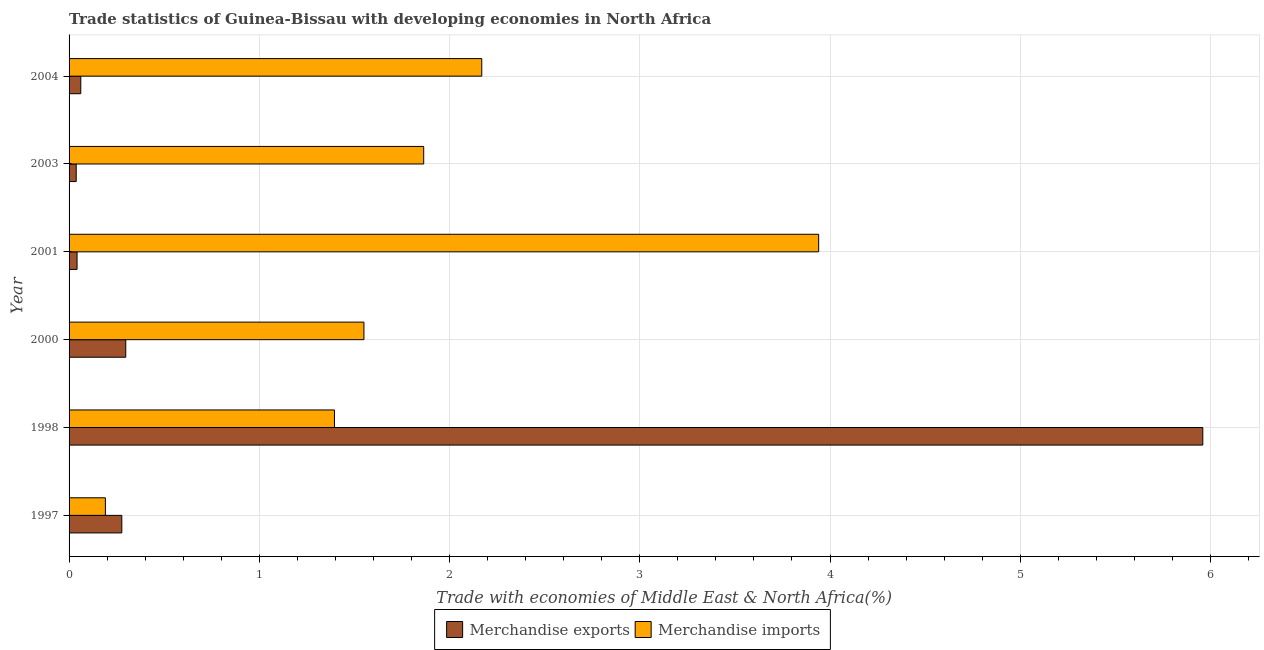How many groups of bars are there?
Offer a very short reply. 6. Are the number of bars on each tick of the Y-axis equal?
Your answer should be very brief. Yes. How many bars are there on the 6th tick from the top?
Provide a short and direct response. 2. What is the merchandise imports in 2003?
Your response must be concise. 1.86. Across all years, what is the maximum merchandise imports?
Keep it short and to the point. 3.94. Across all years, what is the minimum merchandise exports?
Your response must be concise. 0.04. In which year was the merchandise imports maximum?
Keep it short and to the point. 2001. What is the total merchandise imports in the graph?
Make the answer very short. 11.11. What is the difference between the merchandise imports in 2001 and that in 2003?
Your response must be concise. 2.08. What is the difference between the merchandise exports in 1997 and the merchandise imports in 2000?
Ensure brevity in your answer.  -1.27. What is the average merchandise exports per year?
Your response must be concise. 1.11. In the year 1998, what is the difference between the merchandise imports and merchandise exports?
Offer a terse response. -4.56. What is the ratio of the merchandise exports in 2000 to that in 2003?
Make the answer very short. 7.93. What is the difference between the highest and the second highest merchandise imports?
Provide a short and direct response. 1.77. What is the difference between the highest and the lowest merchandise exports?
Offer a very short reply. 5.92. In how many years, is the merchandise exports greater than the average merchandise exports taken over all years?
Offer a very short reply. 1. What does the 1st bar from the bottom in 2003 represents?
Your answer should be compact. Merchandise exports. How many bars are there?
Your answer should be very brief. 12. How many years are there in the graph?
Make the answer very short. 6. What is the difference between two consecutive major ticks on the X-axis?
Offer a very short reply. 1. Are the values on the major ticks of X-axis written in scientific E-notation?
Ensure brevity in your answer.  No. Does the graph contain any zero values?
Provide a short and direct response. No. How are the legend labels stacked?
Keep it short and to the point. Horizontal. What is the title of the graph?
Keep it short and to the point. Trade statistics of Guinea-Bissau with developing economies in North Africa. Does "Secondary Education" appear as one of the legend labels in the graph?
Ensure brevity in your answer.  No. What is the label or title of the X-axis?
Provide a succinct answer. Trade with economies of Middle East & North Africa(%). What is the Trade with economies of Middle East & North Africa(%) in Merchandise exports in 1997?
Give a very brief answer. 0.28. What is the Trade with economies of Middle East & North Africa(%) of Merchandise imports in 1997?
Keep it short and to the point. 0.19. What is the Trade with economies of Middle East & North Africa(%) of Merchandise exports in 1998?
Your answer should be very brief. 5.96. What is the Trade with economies of Middle East & North Africa(%) in Merchandise imports in 1998?
Your response must be concise. 1.4. What is the Trade with economies of Middle East & North Africa(%) of Merchandise exports in 2000?
Offer a terse response. 0.3. What is the Trade with economies of Middle East & North Africa(%) of Merchandise imports in 2000?
Give a very brief answer. 1.55. What is the Trade with economies of Middle East & North Africa(%) of Merchandise exports in 2001?
Keep it short and to the point. 0.04. What is the Trade with economies of Middle East & North Africa(%) in Merchandise imports in 2001?
Your response must be concise. 3.94. What is the Trade with economies of Middle East & North Africa(%) in Merchandise exports in 2003?
Offer a very short reply. 0.04. What is the Trade with economies of Middle East & North Africa(%) of Merchandise imports in 2003?
Give a very brief answer. 1.86. What is the Trade with economies of Middle East & North Africa(%) in Merchandise exports in 2004?
Give a very brief answer. 0.06. What is the Trade with economies of Middle East & North Africa(%) in Merchandise imports in 2004?
Your response must be concise. 2.17. Across all years, what is the maximum Trade with economies of Middle East & North Africa(%) of Merchandise exports?
Give a very brief answer. 5.96. Across all years, what is the maximum Trade with economies of Middle East & North Africa(%) of Merchandise imports?
Provide a short and direct response. 3.94. Across all years, what is the minimum Trade with economies of Middle East & North Africa(%) in Merchandise exports?
Keep it short and to the point. 0.04. Across all years, what is the minimum Trade with economies of Middle East & North Africa(%) of Merchandise imports?
Your answer should be very brief. 0.19. What is the total Trade with economies of Middle East & North Africa(%) of Merchandise exports in the graph?
Offer a terse response. 6.68. What is the total Trade with economies of Middle East & North Africa(%) in Merchandise imports in the graph?
Offer a terse response. 11.11. What is the difference between the Trade with economies of Middle East & North Africa(%) in Merchandise exports in 1997 and that in 1998?
Provide a short and direct response. -5.68. What is the difference between the Trade with economies of Middle East & North Africa(%) in Merchandise imports in 1997 and that in 1998?
Your answer should be compact. -1.2. What is the difference between the Trade with economies of Middle East & North Africa(%) of Merchandise exports in 1997 and that in 2000?
Your answer should be very brief. -0.02. What is the difference between the Trade with economies of Middle East & North Africa(%) in Merchandise imports in 1997 and that in 2000?
Provide a succinct answer. -1.36. What is the difference between the Trade with economies of Middle East & North Africa(%) of Merchandise exports in 1997 and that in 2001?
Make the answer very short. 0.24. What is the difference between the Trade with economies of Middle East & North Africa(%) of Merchandise imports in 1997 and that in 2001?
Your answer should be very brief. -3.75. What is the difference between the Trade with economies of Middle East & North Africa(%) in Merchandise exports in 1997 and that in 2003?
Give a very brief answer. 0.24. What is the difference between the Trade with economies of Middle East & North Africa(%) in Merchandise imports in 1997 and that in 2003?
Make the answer very short. -1.67. What is the difference between the Trade with economies of Middle East & North Africa(%) in Merchandise exports in 1997 and that in 2004?
Offer a very short reply. 0.22. What is the difference between the Trade with economies of Middle East & North Africa(%) in Merchandise imports in 1997 and that in 2004?
Keep it short and to the point. -1.98. What is the difference between the Trade with economies of Middle East & North Africa(%) of Merchandise exports in 1998 and that in 2000?
Provide a short and direct response. 5.66. What is the difference between the Trade with economies of Middle East & North Africa(%) of Merchandise imports in 1998 and that in 2000?
Your answer should be very brief. -0.15. What is the difference between the Trade with economies of Middle East & North Africa(%) in Merchandise exports in 1998 and that in 2001?
Offer a very short reply. 5.92. What is the difference between the Trade with economies of Middle East & North Africa(%) in Merchandise imports in 1998 and that in 2001?
Provide a short and direct response. -2.55. What is the difference between the Trade with economies of Middle East & North Africa(%) of Merchandise exports in 1998 and that in 2003?
Your response must be concise. 5.92. What is the difference between the Trade with economies of Middle East & North Africa(%) in Merchandise imports in 1998 and that in 2003?
Keep it short and to the point. -0.47. What is the difference between the Trade with economies of Middle East & North Africa(%) in Merchandise exports in 1998 and that in 2004?
Provide a short and direct response. 5.9. What is the difference between the Trade with economies of Middle East & North Africa(%) of Merchandise imports in 1998 and that in 2004?
Keep it short and to the point. -0.77. What is the difference between the Trade with economies of Middle East & North Africa(%) of Merchandise exports in 2000 and that in 2001?
Give a very brief answer. 0.26. What is the difference between the Trade with economies of Middle East & North Africa(%) of Merchandise imports in 2000 and that in 2001?
Give a very brief answer. -2.39. What is the difference between the Trade with economies of Middle East & North Africa(%) in Merchandise exports in 2000 and that in 2003?
Ensure brevity in your answer.  0.26. What is the difference between the Trade with economies of Middle East & North Africa(%) of Merchandise imports in 2000 and that in 2003?
Ensure brevity in your answer.  -0.31. What is the difference between the Trade with economies of Middle East & North Africa(%) of Merchandise exports in 2000 and that in 2004?
Make the answer very short. 0.24. What is the difference between the Trade with economies of Middle East & North Africa(%) in Merchandise imports in 2000 and that in 2004?
Offer a terse response. -0.62. What is the difference between the Trade with economies of Middle East & North Africa(%) of Merchandise exports in 2001 and that in 2003?
Your answer should be compact. 0. What is the difference between the Trade with economies of Middle East & North Africa(%) of Merchandise imports in 2001 and that in 2003?
Provide a succinct answer. 2.08. What is the difference between the Trade with economies of Middle East & North Africa(%) of Merchandise exports in 2001 and that in 2004?
Ensure brevity in your answer.  -0.02. What is the difference between the Trade with economies of Middle East & North Africa(%) in Merchandise imports in 2001 and that in 2004?
Offer a terse response. 1.77. What is the difference between the Trade with economies of Middle East & North Africa(%) of Merchandise exports in 2003 and that in 2004?
Give a very brief answer. -0.02. What is the difference between the Trade with economies of Middle East & North Africa(%) in Merchandise imports in 2003 and that in 2004?
Make the answer very short. -0.31. What is the difference between the Trade with economies of Middle East & North Africa(%) in Merchandise exports in 1997 and the Trade with economies of Middle East & North Africa(%) in Merchandise imports in 1998?
Provide a short and direct response. -1.12. What is the difference between the Trade with economies of Middle East & North Africa(%) of Merchandise exports in 1997 and the Trade with economies of Middle East & North Africa(%) of Merchandise imports in 2000?
Keep it short and to the point. -1.27. What is the difference between the Trade with economies of Middle East & North Africa(%) in Merchandise exports in 1997 and the Trade with economies of Middle East & North Africa(%) in Merchandise imports in 2001?
Make the answer very short. -3.66. What is the difference between the Trade with economies of Middle East & North Africa(%) in Merchandise exports in 1997 and the Trade with economies of Middle East & North Africa(%) in Merchandise imports in 2003?
Offer a very short reply. -1.59. What is the difference between the Trade with economies of Middle East & North Africa(%) of Merchandise exports in 1997 and the Trade with economies of Middle East & North Africa(%) of Merchandise imports in 2004?
Your response must be concise. -1.89. What is the difference between the Trade with economies of Middle East & North Africa(%) in Merchandise exports in 1998 and the Trade with economies of Middle East & North Africa(%) in Merchandise imports in 2000?
Make the answer very short. 4.41. What is the difference between the Trade with economies of Middle East & North Africa(%) in Merchandise exports in 1998 and the Trade with economies of Middle East & North Africa(%) in Merchandise imports in 2001?
Provide a short and direct response. 2.02. What is the difference between the Trade with economies of Middle East & North Africa(%) in Merchandise exports in 1998 and the Trade with economies of Middle East & North Africa(%) in Merchandise imports in 2003?
Keep it short and to the point. 4.1. What is the difference between the Trade with economies of Middle East & North Africa(%) of Merchandise exports in 1998 and the Trade with economies of Middle East & North Africa(%) of Merchandise imports in 2004?
Provide a succinct answer. 3.79. What is the difference between the Trade with economies of Middle East & North Africa(%) in Merchandise exports in 2000 and the Trade with economies of Middle East & North Africa(%) in Merchandise imports in 2001?
Provide a succinct answer. -3.64. What is the difference between the Trade with economies of Middle East & North Africa(%) in Merchandise exports in 2000 and the Trade with economies of Middle East & North Africa(%) in Merchandise imports in 2003?
Give a very brief answer. -1.57. What is the difference between the Trade with economies of Middle East & North Africa(%) of Merchandise exports in 2000 and the Trade with economies of Middle East & North Africa(%) of Merchandise imports in 2004?
Keep it short and to the point. -1.87. What is the difference between the Trade with economies of Middle East & North Africa(%) in Merchandise exports in 2001 and the Trade with economies of Middle East & North Africa(%) in Merchandise imports in 2003?
Your answer should be compact. -1.82. What is the difference between the Trade with economies of Middle East & North Africa(%) of Merchandise exports in 2001 and the Trade with economies of Middle East & North Africa(%) of Merchandise imports in 2004?
Offer a very short reply. -2.13. What is the difference between the Trade with economies of Middle East & North Africa(%) of Merchandise exports in 2003 and the Trade with economies of Middle East & North Africa(%) of Merchandise imports in 2004?
Give a very brief answer. -2.13. What is the average Trade with economies of Middle East & North Africa(%) in Merchandise exports per year?
Make the answer very short. 1.11. What is the average Trade with economies of Middle East & North Africa(%) in Merchandise imports per year?
Your answer should be very brief. 1.85. In the year 1997, what is the difference between the Trade with economies of Middle East & North Africa(%) in Merchandise exports and Trade with economies of Middle East & North Africa(%) in Merchandise imports?
Your answer should be very brief. 0.09. In the year 1998, what is the difference between the Trade with economies of Middle East & North Africa(%) in Merchandise exports and Trade with economies of Middle East & North Africa(%) in Merchandise imports?
Give a very brief answer. 4.56. In the year 2000, what is the difference between the Trade with economies of Middle East & North Africa(%) in Merchandise exports and Trade with economies of Middle East & North Africa(%) in Merchandise imports?
Provide a succinct answer. -1.25. In the year 2001, what is the difference between the Trade with economies of Middle East & North Africa(%) in Merchandise exports and Trade with economies of Middle East & North Africa(%) in Merchandise imports?
Keep it short and to the point. -3.9. In the year 2003, what is the difference between the Trade with economies of Middle East & North Africa(%) in Merchandise exports and Trade with economies of Middle East & North Africa(%) in Merchandise imports?
Make the answer very short. -1.83. In the year 2004, what is the difference between the Trade with economies of Middle East & North Africa(%) of Merchandise exports and Trade with economies of Middle East & North Africa(%) of Merchandise imports?
Your answer should be very brief. -2.11. What is the ratio of the Trade with economies of Middle East & North Africa(%) in Merchandise exports in 1997 to that in 1998?
Keep it short and to the point. 0.05. What is the ratio of the Trade with economies of Middle East & North Africa(%) in Merchandise imports in 1997 to that in 1998?
Your response must be concise. 0.14. What is the ratio of the Trade with economies of Middle East & North Africa(%) in Merchandise exports in 1997 to that in 2000?
Ensure brevity in your answer.  0.93. What is the ratio of the Trade with economies of Middle East & North Africa(%) of Merchandise imports in 1997 to that in 2000?
Keep it short and to the point. 0.12. What is the ratio of the Trade with economies of Middle East & North Africa(%) of Merchandise exports in 1997 to that in 2001?
Give a very brief answer. 6.6. What is the ratio of the Trade with economies of Middle East & North Africa(%) in Merchandise imports in 1997 to that in 2001?
Your answer should be very brief. 0.05. What is the ratio of the Trade with economies of Middle East & North Africa(%) of Merchandise exports in 1997 to that in 2003?
Provide a succinct answer. 7.37. What is the ratio of the Trade with economies of Middle East & North Africa(%) of Merchandise imports in 1997 to that in 2003?
Ensure brevity in your answer.  0.1. What is the ratio of the Trade with economies of Middle East & North Africa(%) of Merchandise exports in 1997 to that in 2004?
Ensure brevity in your answer.  4.5. What is the ratio of the Trade with economies of Middle East & North Africa(%) of Merchandise imports in 1997 to that in 2004?
Your answer should be very brief. 0.09. What is the ratio of the Trade with economies of Middle East & North Africa(%) in Merchandise exports in 1998 to that in 2000?
Make the answer very short. 20. What is the ratio of the Trade with economies of Middle East & North Africa(%) of Merchandise imports in 1998 to that in 2000?
Make the answer very short. 0.9. What is the ratio of the Trade with economies of Middle East & North Africa(%) of Merchandise exports in 1998 to that in 2001?
Offer a terse response. 141.95. What is the ratio of the Trade with economies of Middle East & North Africa(%) of Merchandise imports in 1998 to that in 2001?
Provide a succinct answer. 0.35. What is the ratio of the Trade with economies of Middle East & North Africa(%) in Merchandise exports in 1998 to that in 2003?
Offer a very short reply. 158.51. What is the ratio of the Trade with economies of Middle East & North Africa(%) in Merchandise imports in 1998 to that in 2003?
Ensure brevity in your answer.  0.75. What is the ratio of the Trade with economies of Middle East & North Africa(%) of Merchandise exports in 1998 to that in 2004?
Keep it short and to the point. 96.81. What is the ratio of the Trade with economies of Middle East & North Africa(%) in Merchandise imports in 1998 to that in 2004?
Provide a short and direct response. 0.64. What is the ratio of the Trade with economies of Middle East & North Africa(%) in Merchandise exports in 2000 to that in 2001?
Make the answer very short. 7.1. What is the ratio of the Trade with economies of Middle East & North Africa(%) in Merchandise imports in 2000 to that in 2001?
Your answer should be compact. 0.39. What is the ratio of the Trade with economies of Middle East & North Africa(%) in Merchandise exports in 2000 to that in 2003?
Offer a terse response. 7.93. What is the ratio of the Trade with economies of Middle East & North Africa(%) of Merchandise imports in 2000 to that in 2003?
Your answer should be very brief. 0.83. What is the ratio of the Trade with economies of Middle East & North Africa(%) of Merchandise exports in 2000 to that in 2004?
Make the answer very short. 4.84. What is the ratio of the Trade with economies of Middle East & North Africa(%) in Merchandise imports in 2000 to that in 2004?
Give a very brief answer. 0.71. What is the ratio of the Trade with economies of Middle East & North Africa(%) of Merchandise exports in 2001 to that in 2003?
Give a very brief answer. 1.12. What is the ratio of the Trade with economies of Middle East & North Africa(%) in Merchandise imports in 2001 to that in 2003?
Your response must be concise. 2.11. What is the ratio of the Trade with economies of Middle East & North Africa(%) in Merchandise exports in 2001 to that in 2004?
Give a very brief answer. 0.68. What is the ratio of the Trade with economies of Middle East & North Africa(%) in Merchandise imports in 2001 to that in 2004?
Your answer should be compact. 1.82. What is the ratio of the Trade with economies of Middle East & North Africa(%) of Merchandise exports in 2003 to that in 2004?
Provide a short and direct response. 0.61. What is the ratio of the Trade with economies of Middle East & North Africa(%) of Merchandise imports in 2003 to that in 2004?
Offer a terse response. 0.86. What is the difference between the highest and the second highest Trade with economies of Middle East & North Africa(%) of Merchandise exports?
Offer a very short reply. 5.66. What is the difference between the highest and the second highest Trade with economies of Middle East & North Africa(%) of Merchandise imports?
Your answer should be compact. 1.77. What is the difference between the highest and the lowest Trade with economies of Middle East & North Africa(%) of Merchandise exports?
Your answer should be compact. 5.92. What is the difference between the highest and the lowest Trade with economies of Middle East & North Africa(%) in Merchandise imports?
Make the answer very short. 3.75. 